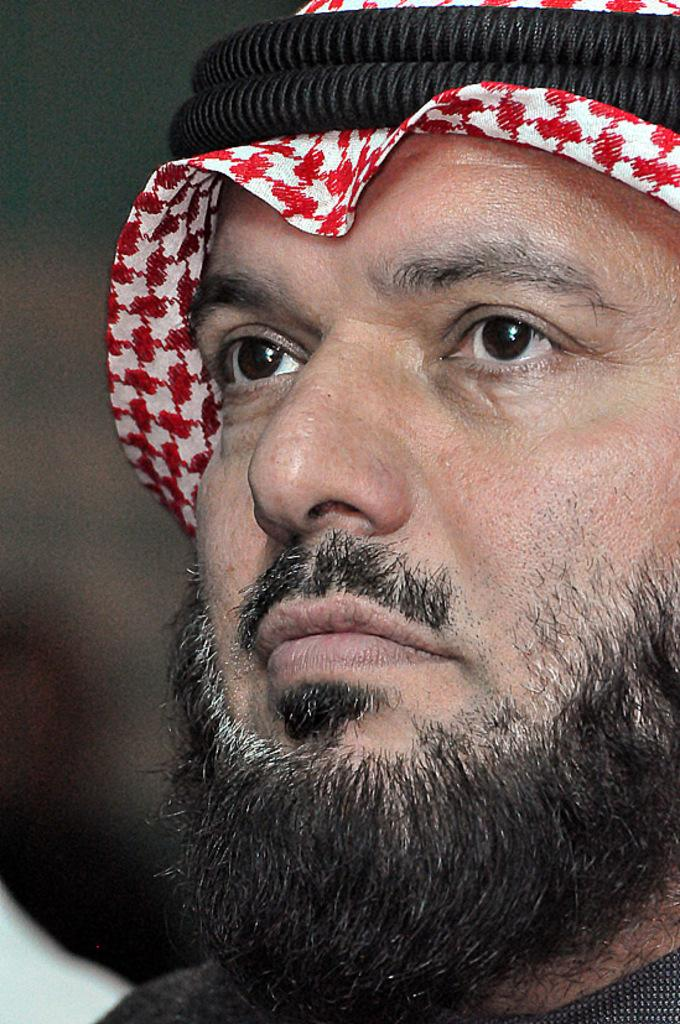What is the main subject of the image? The main subject of the image is a man. Can you describe the man's appearance in the image? The man is wearing a head cap and has a beard. What type of quartz can be seen in the man's beard in the image? There is no quartz present in the image, and the man's beard does not contain any quartz. 